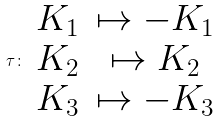<formula> <loc_0><loc_0><loc_500><loc_500>\tau \colon \begin{array} { c c } K _ { 1 } & \mapsto - K _ { 1 } \\ K _ { 2 } & \mapsto K _ { 2 } \\ K _ { 3 } & \mapsto - K _ { 3 } \end{array}</formula> 